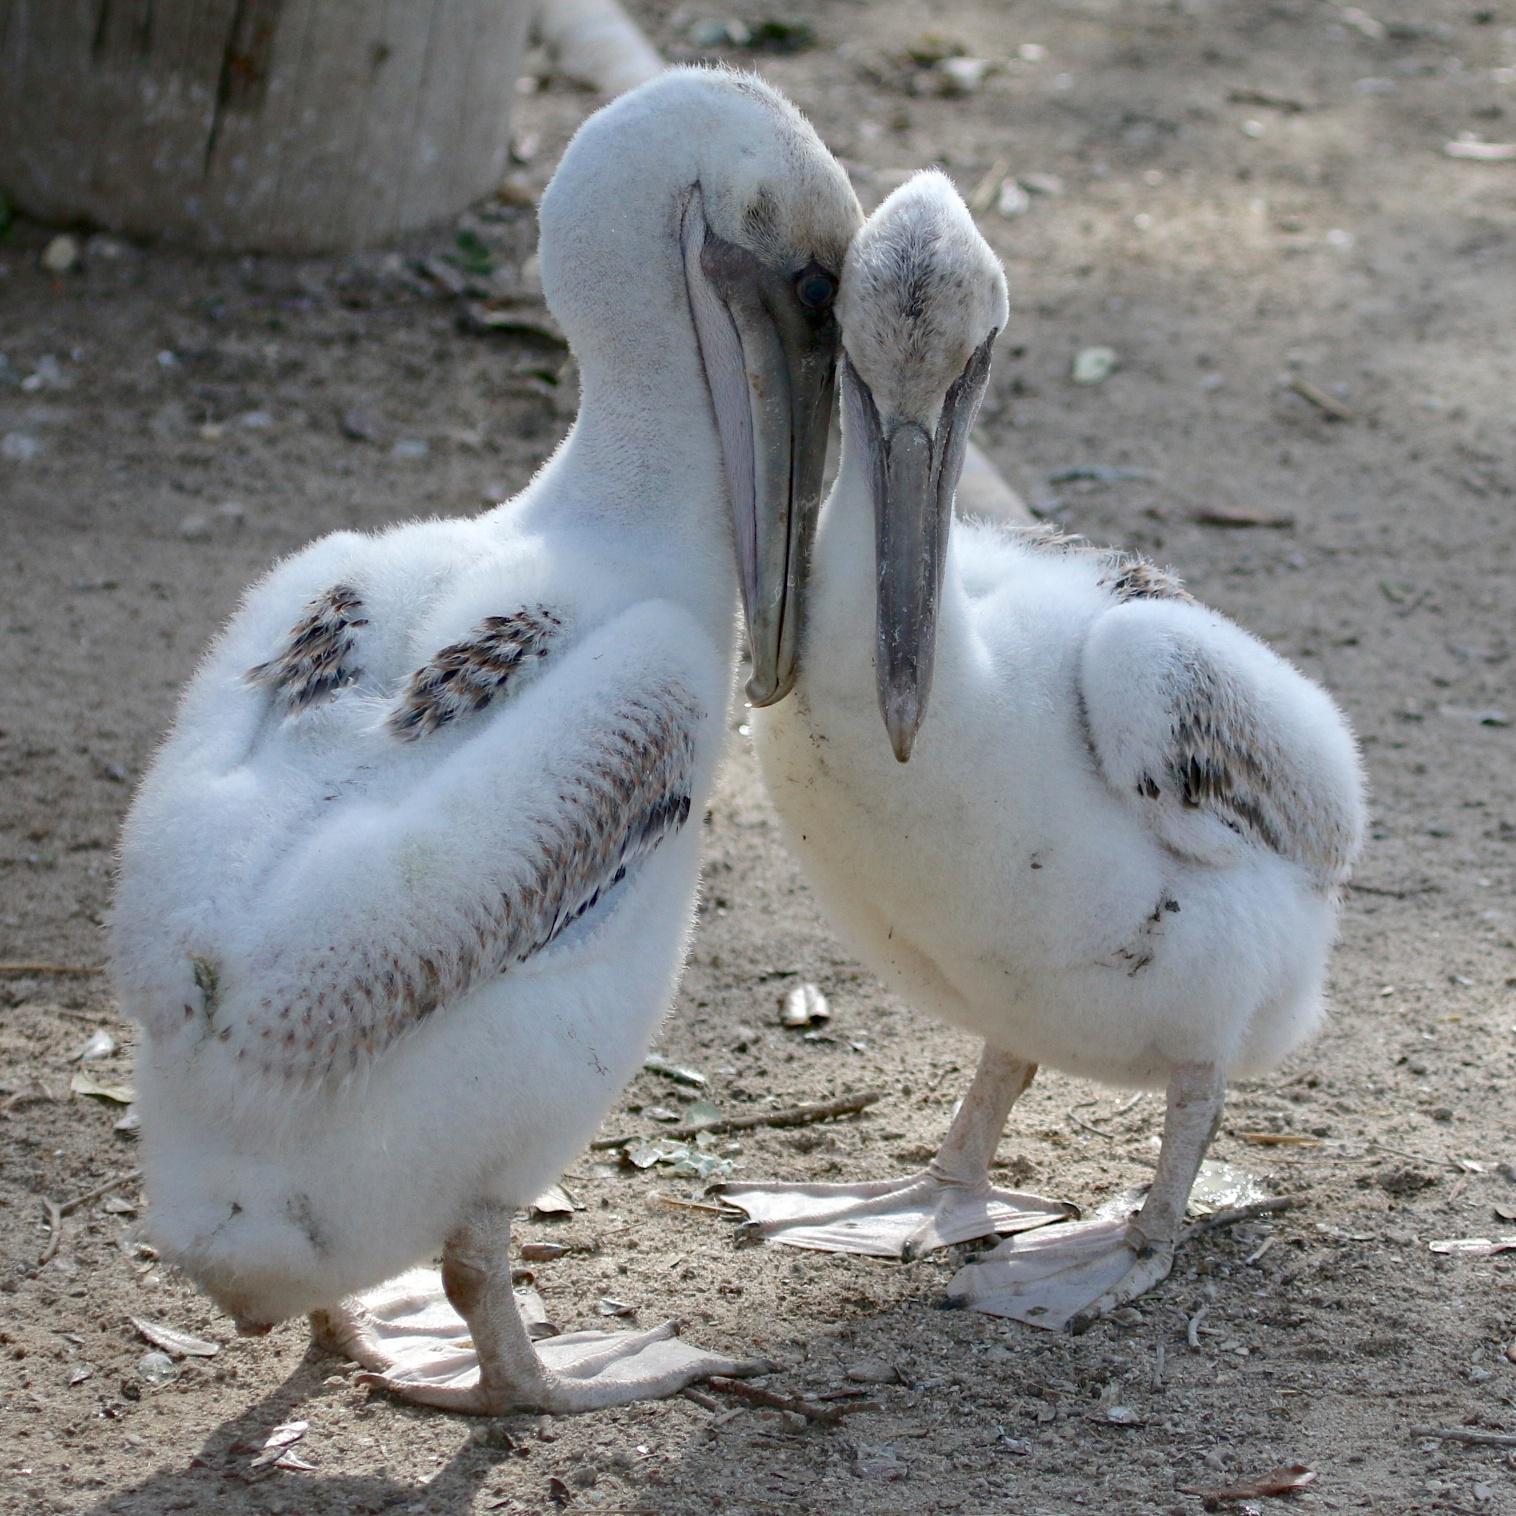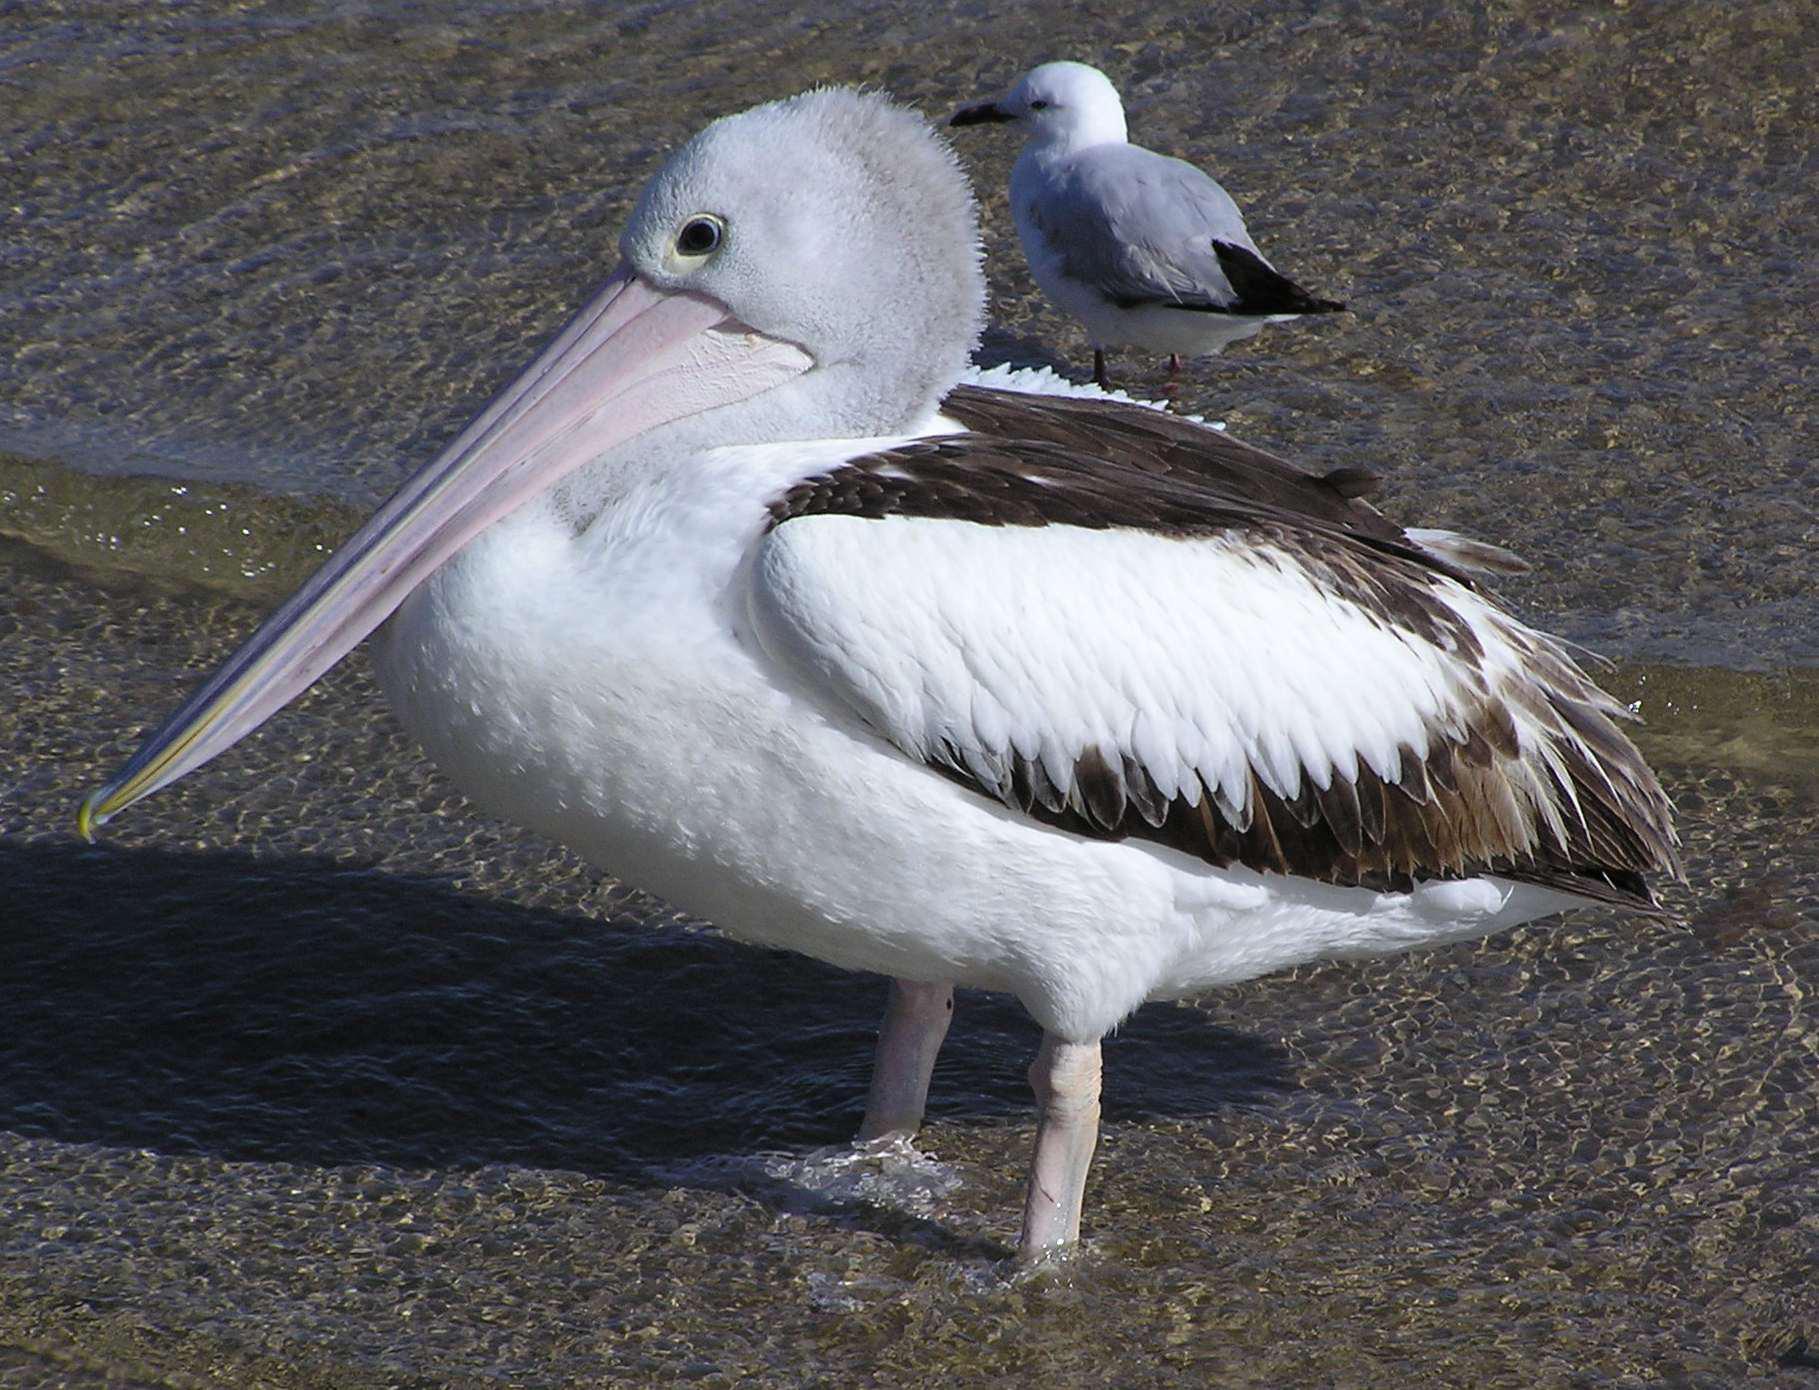The first image is the image on the left, the second image is the image on the right. For the images shown, is this caption "The bird in the image on the right is in a wet area." true? Answer yes or no. Yes. The first image is the image on the left, the second image is the image on the right. Considering the images on both sides, is "An image shows a nest that includes a pelican with an open mouth in it." valid? Answer yes or no. No. 